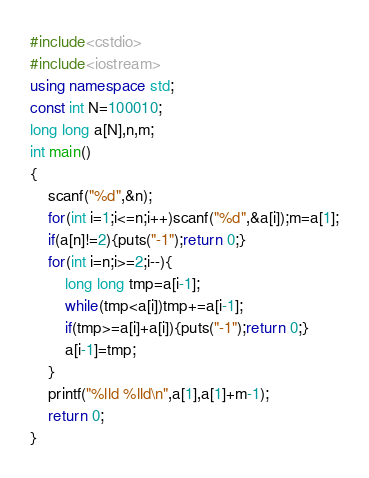Convert code to text. <code><loc_0><loc_0><loc_500><loc_500><_C++_>#include<cstdio>
#include<iostream>
using namespace std;
const int N=100010;
long long a[N],n,m;
int main()
{
	scanf("%d",&n);
	for(int i=1;i<=n;i++)scanf("%d",&a[i]);m=a[1];
	if(a[n]!=2){puts("-1");return 0;}
	for(int i=n;i>=2;i--){
		long long tmp=a[i-1];
		while(tmp<a[i])tmp+=a[i-1];
		if(tmp>=a[i]+a[i]){puts("-1");return 0;}
		a[i-1]=tmp;
	}
	printf("%lld %lld\n",a[1],a[1]+m-1);
	return 0;
}</code> 